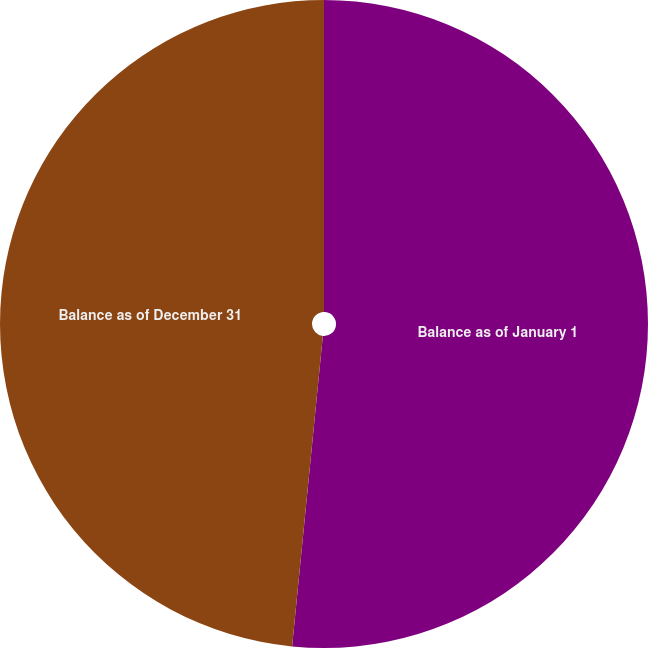Convert chart. <chart><loc_0><loc_0><loc_500><loc_500><pie_chart><fcel>Balance as of January 1<fcel>Balance as of December 31<nl><fcel>51.57%<fcel>48.43%<nl></chart> 